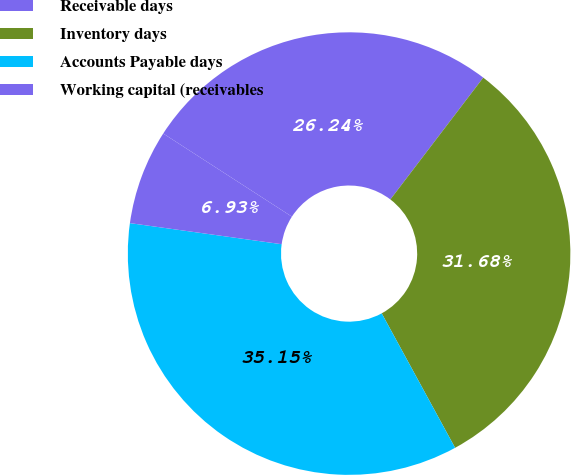Convert chart. <chart><loc_0><loc_0><loc_500><loc_500><pie_chart><fcel>Receivable days<fcel>Inventory days<fcel>Accounts Payable days<fcel>Working capital (receivables<nl><fcel>26.24%<fcel>31.68%<fcel>35.15%<fcel>6.93%<nl></chart> 